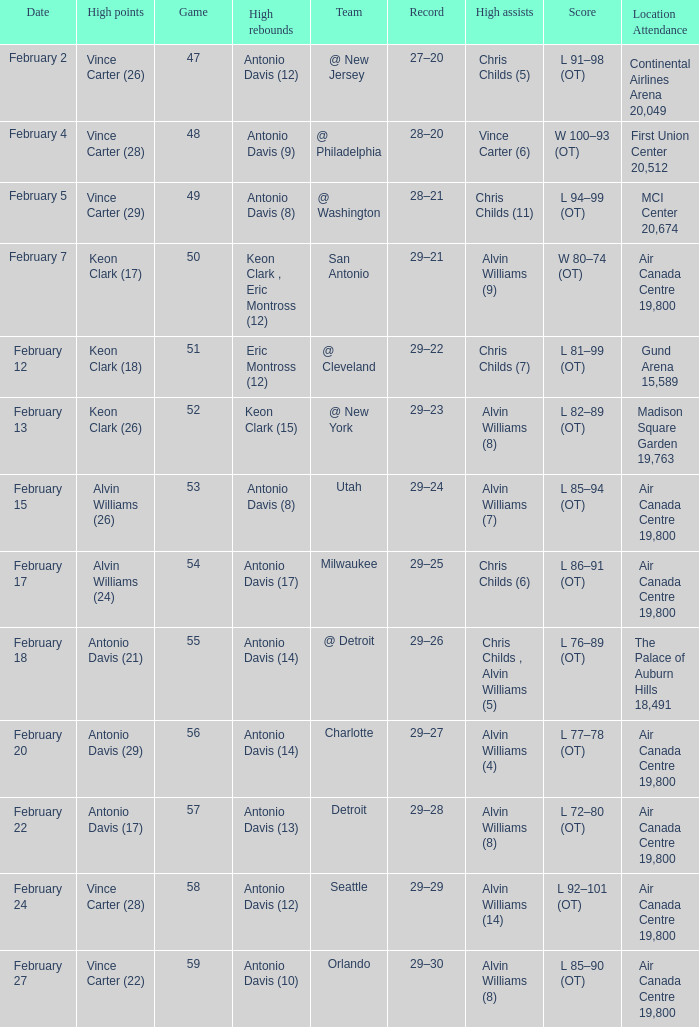What is the Team with a game of more than 56, and the score is l 85–90 (ot)? Orlando. 